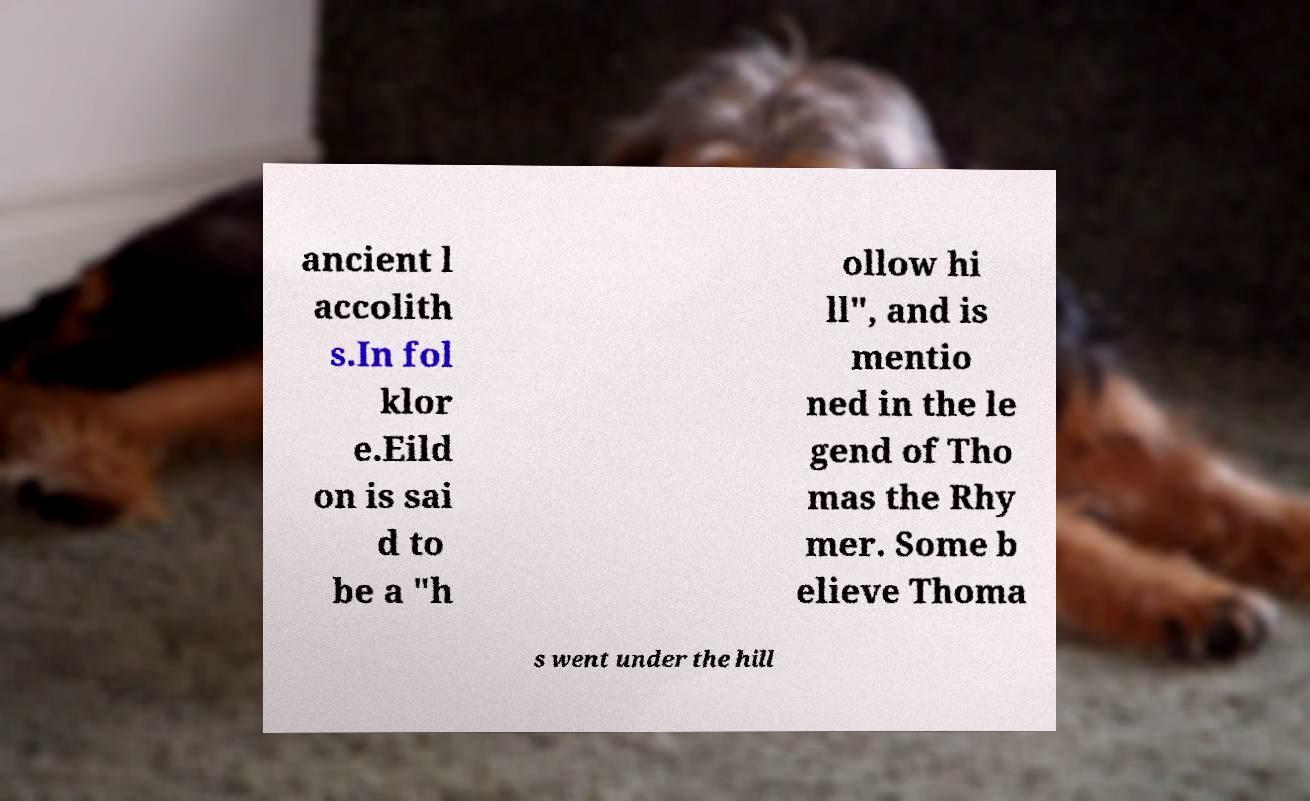Could you extract and type out the text from this image? ancient l accolith s.In fol klor e.Eild on is sai d to be a "h ollow hi ll", and is mentio ned in the le gend of Tho mas the Rhy mer. Some b elieve Thoma s went under the hill 